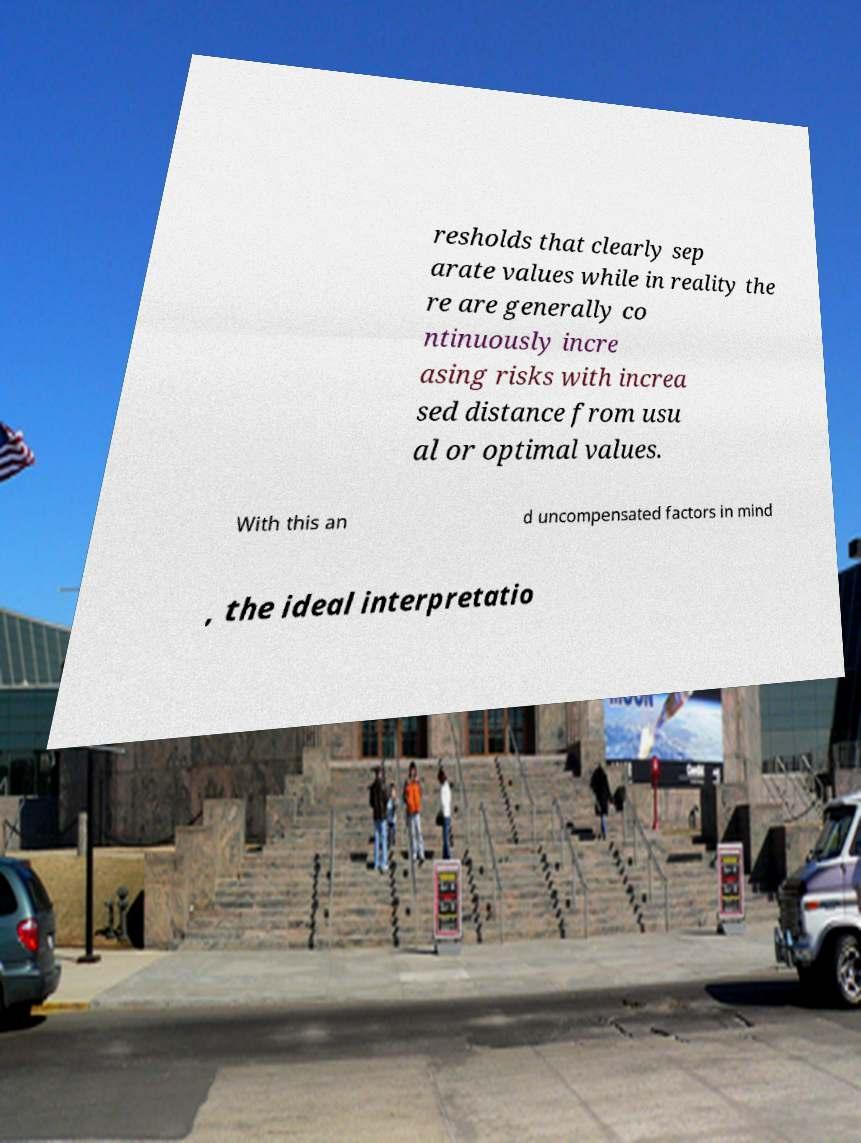I need the written content from this picture converted into text. Can you do that? resholds that clearly sep arate values while in reality the re are generally co ntinuously incre asing risks with increa sed distance from usu al or optimal values. With this an d uncompensated factors in mind , the ideal interpretatio 